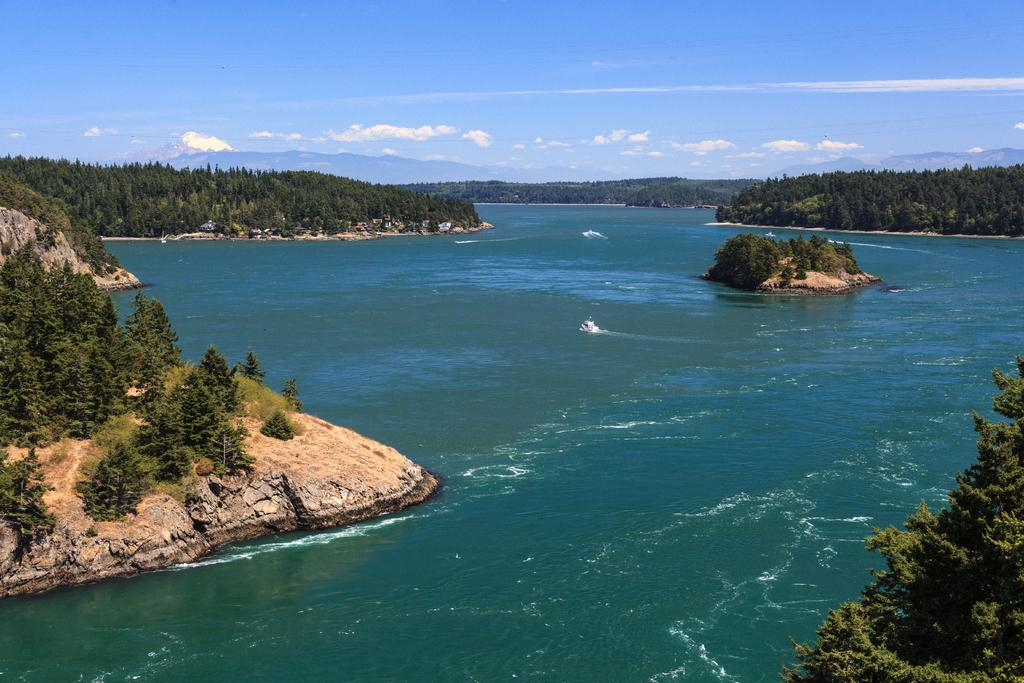What is the main feature in the center of the image? There is a river in the center of the image. What type of vegetation can be seen in the image? There are trees in the image. What can be seen in the distance in the image? There are hills visible in the background of the image. What is visible above the landscape in the image? The sky is visible in the background of the image. What type of farming equipment can be seen in the image? There is no farming equipment present in the image. What angle is the flight taking in the image? There is no flight present in the image. 